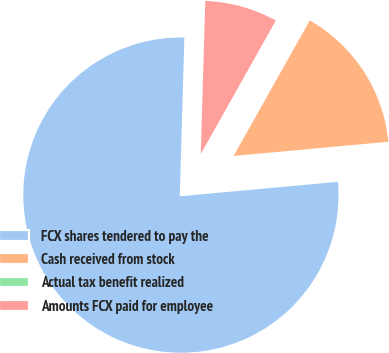Convert chart. <chart><loc_0><loc_0><loc_500><loc_500><pie_chart><fcel>FCX shares tendered to pay the<fcel>Cash received from stock<fcel>Actual tax benefit realized<fcel>Amounts FCX paid for employee<nl><fcel>76.92%<fcel>15.39%<fcel>0.0%<fcel>7.69%<nl></chart> 